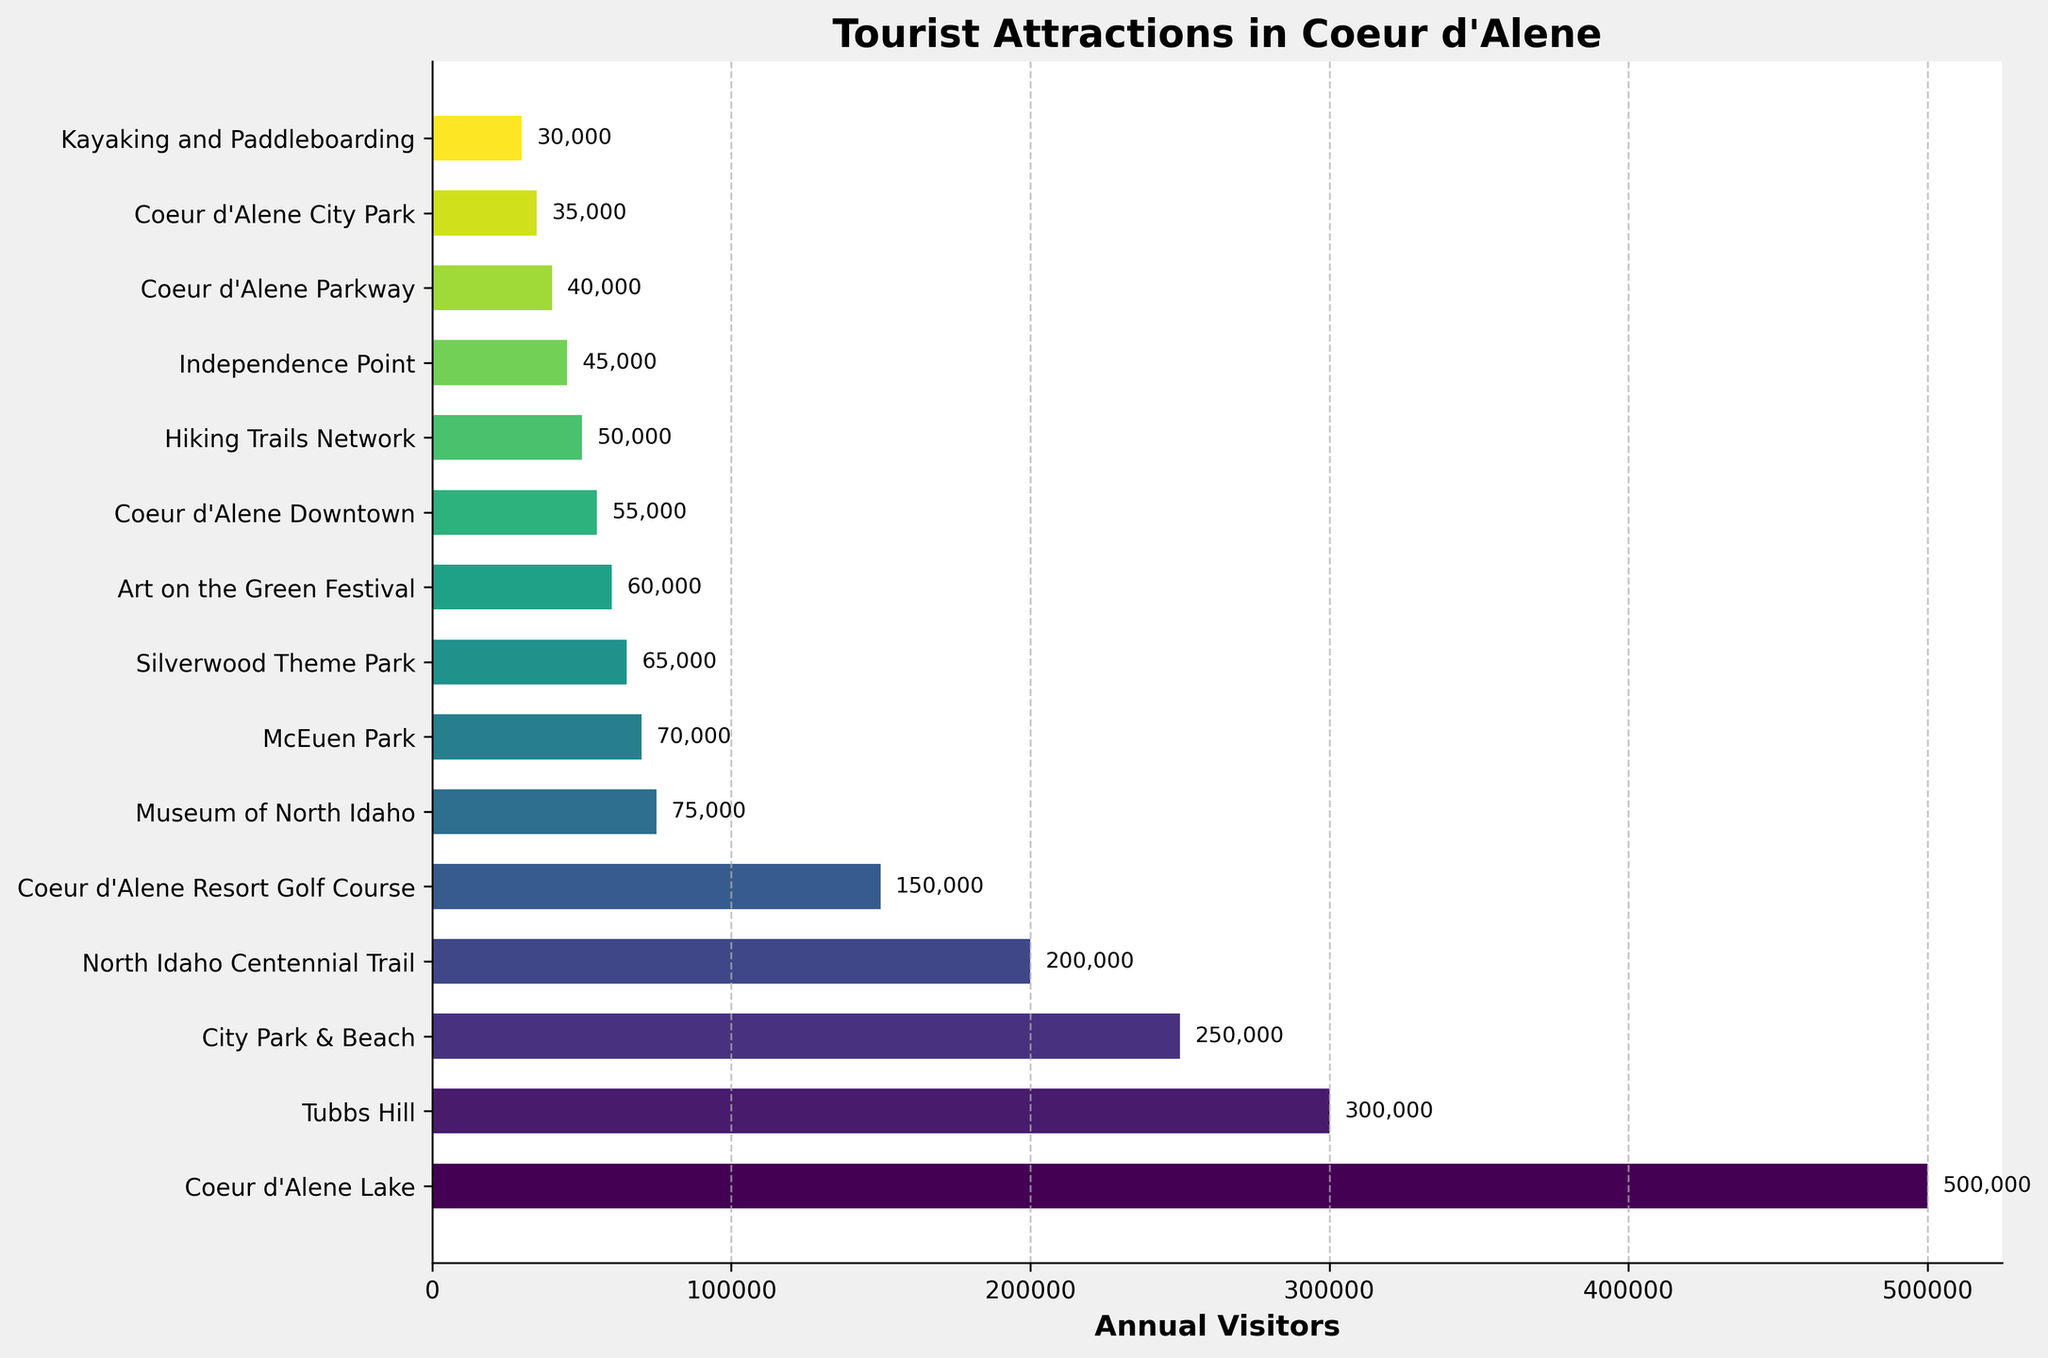Which attraction has the highest annual visitor count? The attraction with the highest annual visitor count is identified by the longest bar in the bar chart. In this case, Coeur d'Alene Lake has the longest bar, indicating it has the highest annual visitor count.
Answer: Coeur d'Alene Lake Which attraction has the fewest annual visitors? The attraction with the fewest annual visitors is identified by the shortest bar in the bar chart. In this case, Kayaking and Paddleboarding has the shortest bar, indicating it has the fewest annual visitors.
Answer: Kayaking and Paddleboarding What is the total annual visitor count for Tubbs Hill and City Park & Beach combined? To find the total, add the annual visitors of Tubbs Hill (300,000) and City Park & Beach (250,000). 300,000 + 250,000 = 550,000.
Answer: 550,000 How many more annual visitors does Coeur d'Alene Lake receive compared to Tubbs Hill? Find the difference between the annual visitors of Coeur d'Alene Lake (500,000) and Tubbs Hill (300,000). 500,000 - 300,000 = 200,000.
Answer: 200,000 Which attractions have between 50,000 and 100,000 annual visitors? Identify the bars that fall between the values of 50,000 and 100,000 annual visitors. These attractions are Silverwood Theme Park (65,000), Art on the Green Festival (60,000), Coeur d'Alene Downtown (55,000), and Hiking Trails Network (50,000).
Answer: Silverwood Theme Park, Art on the Green Festival, Coeur d'Alene Downtown, Hiking Trails Network What is the average annual visitor count for the attractions listed? Sum the annual visitor counts of all attractions and divide by the number of attractions. Total visitors: 500,000 + 300,000 + 250,000 + 200,000 + 150,000 + 75,000 + 70,000 + 65,000 + 60,000 + 55,000 + 50,000 + 45,000 + 40,000 + 35,000 + 30,000 = 1,925,000. Number of attractions: 15. The average is 1,925,000 / 15 = 128,333.
Answer: 128,333 Which three attractions have the highest number of annual visitors? Identify the three longest bars in the bar chart. The three attractions with the highest number of annual visitors are Coeur d'Alene Lake (500,000), Tubbs Hill (300,000), and City Park & Beach (250,000).
Answer: Coeur d'Alene Lake, Tubbs Hill, City Park & Beach What is the visitor count difference between Museum of North Idaho and McEuen Park? Find the difference between the annual visitors of Museum of North Idaho (75,000) and McEuen Park (70,000). 75,000 - 70,000 = 5,000.
Answer: 5,000 Based on the bar colors, which attraction has a similar color to North Idaho Centennial Trail? Examine the bar colors to find the one that visually matches most closely with North Idaho Centennial Trail. Art on the Green Festival has a visually similar color.
Answer: Art on the Green Festival 